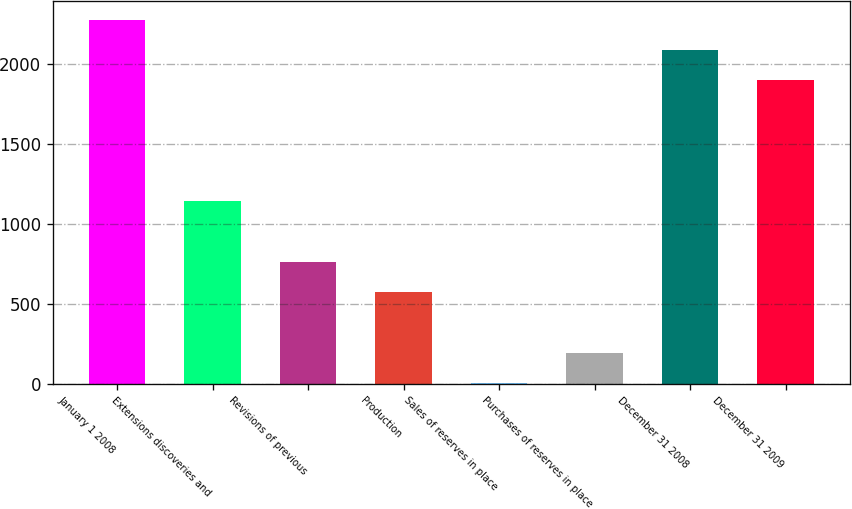<chart> <loc_0><loc_0><loc_500><loc_500><bar_chart><fcel>January 1 2008<fcel>Extensions discoveries and<fcel>Revisions of previous<fcel>Production<fcel>Sales of reserves in place<fcel>Purchases of reserves in place<fcel>December 31 2008<fcel>December 31 2009<nl><fcel>2275<fcel>1138<fcel>759<fcel>569.5<fcel>1<fcel>190.5<fcel>2085.5<fcel>1896<nl></chart> 